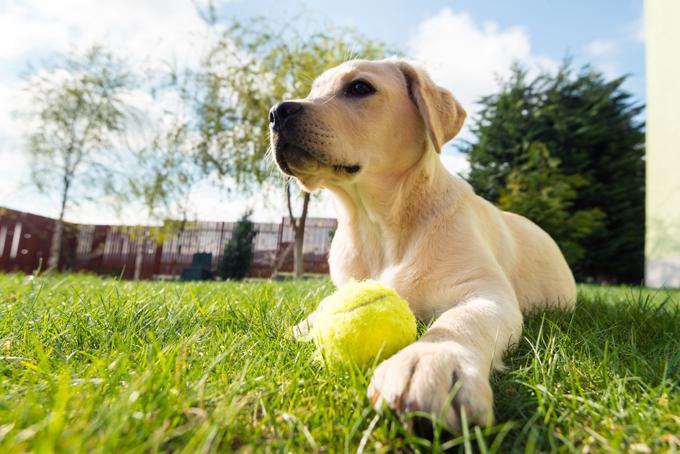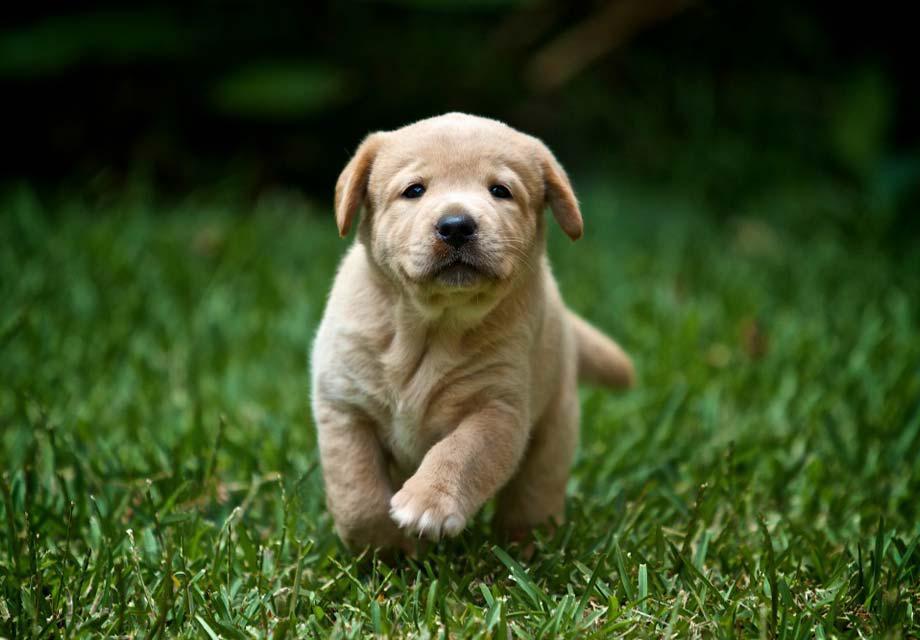The first image is the image on the left, the second image is the image on the right. Considering the images on both sides, is "A ball sits on the grass in front of one of the dogs." valid? Answer yes or no. Yes. The first image is the image on the left, the second image is the image on the right. For the images displayed, is the sentence "An image shows one dog in the grass with a ball." factually correct? Answer yes or no. Yes. 